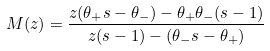Convert formula to latex. <formula><loc_0><loc_0><loc_500><loc_500>M ( z ) = \frac { z ( \theta _ { + } s - \theta _ { - } ) - \theta _ { + } \theta _ { - } ( s - 1 ) } { z ( s - 1 ) - ( \theta _ { - } s - \theta _ { + } ) }</formula> 